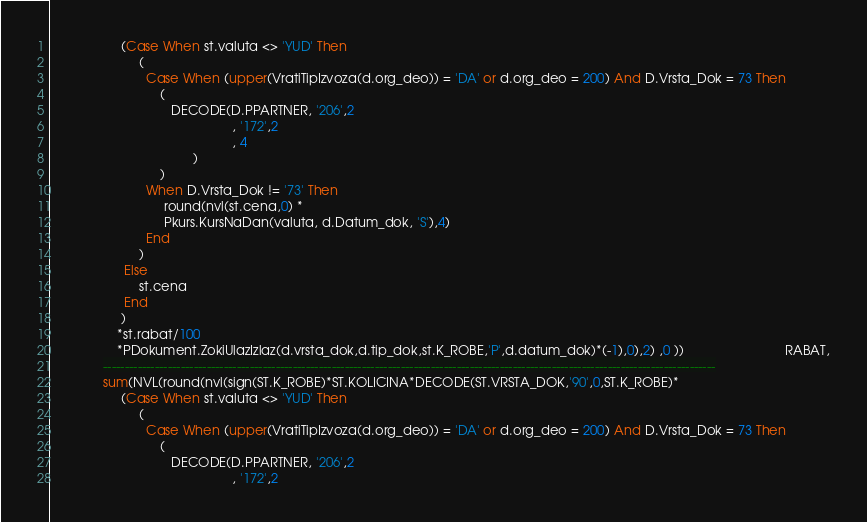Convert code to text. <code><loc_0><loc_0><loc_500><loc_500><_SQL_>                    (Case When st.valuta <> 'YUD' Then
                         (
                           Case When (upper(VratiTipIzvoza(d.org_deo)) = 'DA' or d.org_deo = 200) And D.Vrsta_Dok = 73 Then
                               (
	                              DECODE(D.PPARTNER, '206',2
	                                               , '172',2
	                                               , 4
	                                    )
                               )
                           When D.Vrsta_Dok != '73' Then
                                round(nvl(st.cena,0) *
                                Pkurs.KursNaDan(valuta, d.Datum_dok, 'S'),4)
                           End
                         )
                     Else
                         st.cena
                     End
                    )
                   *st.rabat/100
                   *PDokument.ZokiUlazIzlaz(d.vrsta_dok,d.tip_dok,st.K_ROBE,'P',d.datum_dok)*(-1),0),2) ,0 ))                            RABAT,
               ----------------------------------------------------------------------------------------------------------------------------------------------
               sum(NVL(round(nvl(sign(ST.K_ROBE)*ST.KOLICINA*DECODE(ST.VRSTA_DOK,'90',0,ST.K_ROBE)*
                    (Case When st.valuta <> 'YUD' Then
                         (
                           Case When (upper(VratiTipIzvoza(d.org_deo)) = 'DA' or d.org_deo = 200) And D.Vrsta_Dok = 73 Then
                               (
	                              DECODE(D.PPARTNER, '206',2
	                                               , '172',2</code> 